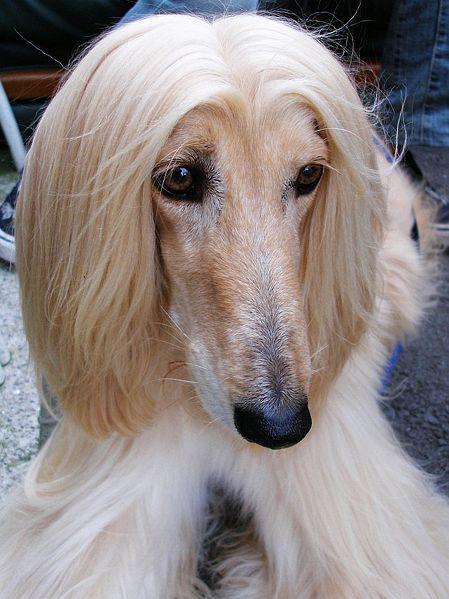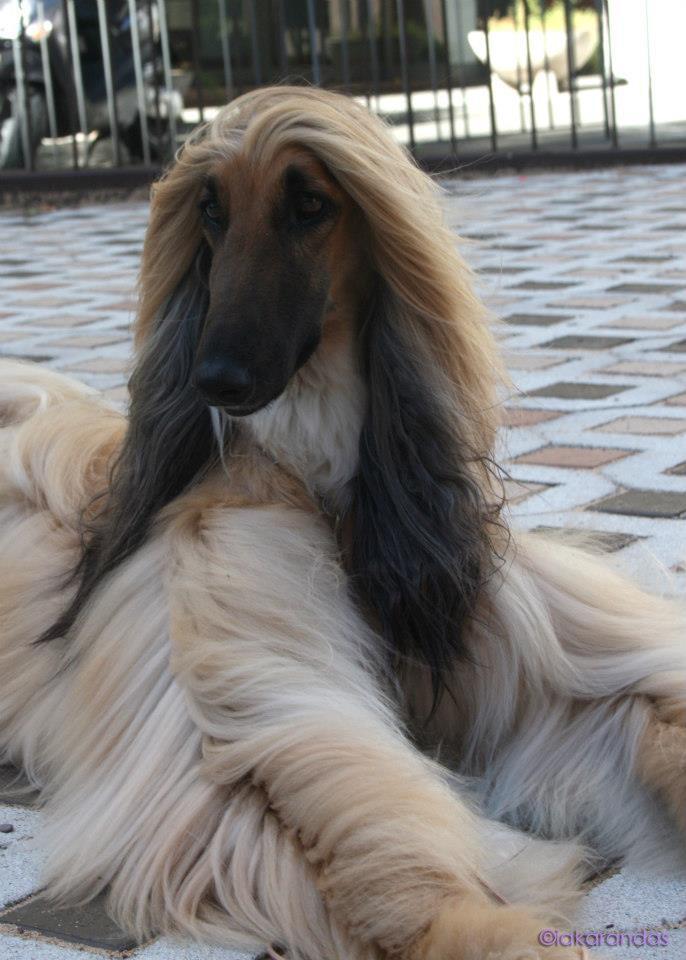The first image is the image on the left, the second image is the image on the right. For the images displayed, is the sentence "There are more dogs in the image on the left." factually correct? Answer yes or no. No. The first image is the image on the left, the second image is the image on the right. For the images shown, is this caption "Each image contains one afghan hound, all hounds are primarily light colored, and one hound sits upright while the other is reclining." true? Answer yes or no. No. 